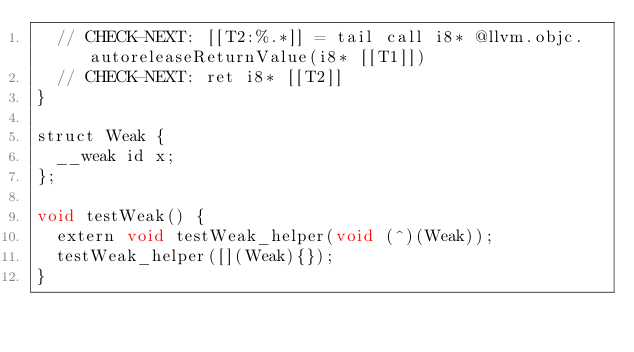Convert code to text. <code><loc_0><loc_0><loc_500><loc_500><_ObjectiveC_>  // CHECK-NEXT: [[T2:%.*]] = tail call i8* @llvm.objc.autoreleaseReturnValue(i8* [[T1]])
  // CHECK-NEXT: ret i8* [[T2]]
}

struct Weak {
  __weak id x;
};

void testWeak() {
  extern void testWeak_helper(void (^)(Weak));
  testWeak_helper([](Weak){});
}
</code> 